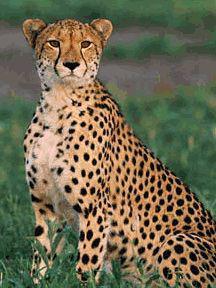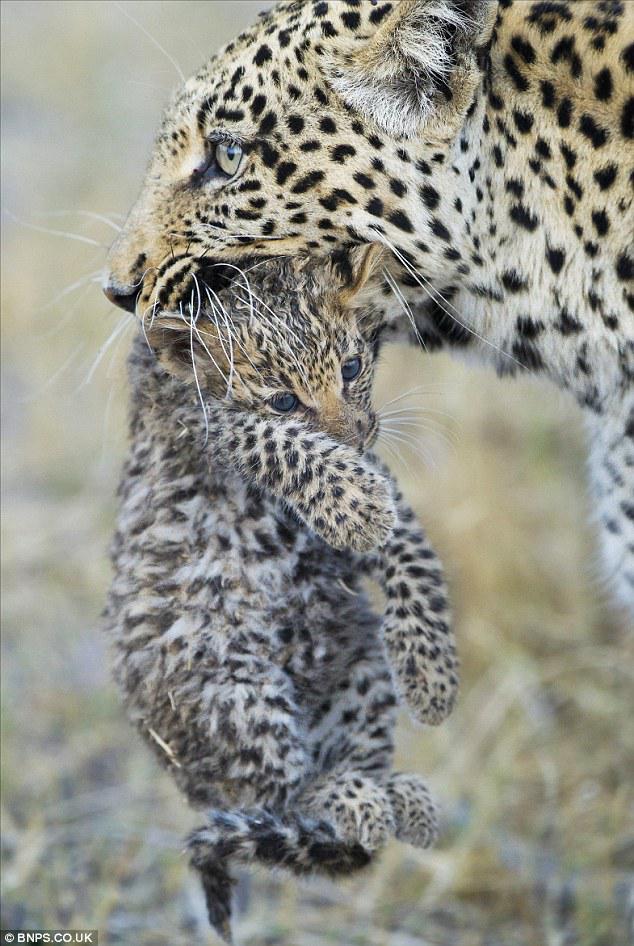The first image is the image on the left, the second image is the image on the right. Evaluate the accuracy of this statement regarding the images: "A spotted adult wildcat is carrying a dangling kitten in its mouth in one image.". Is it true? Answer yes or no. Yes. The first image is the image on the left, the second image is the image on the right. Evaluate the accuracy of this statement regarding the images: "The left image contains two cheetahs.". Is it true? Answer yes or no. No. 